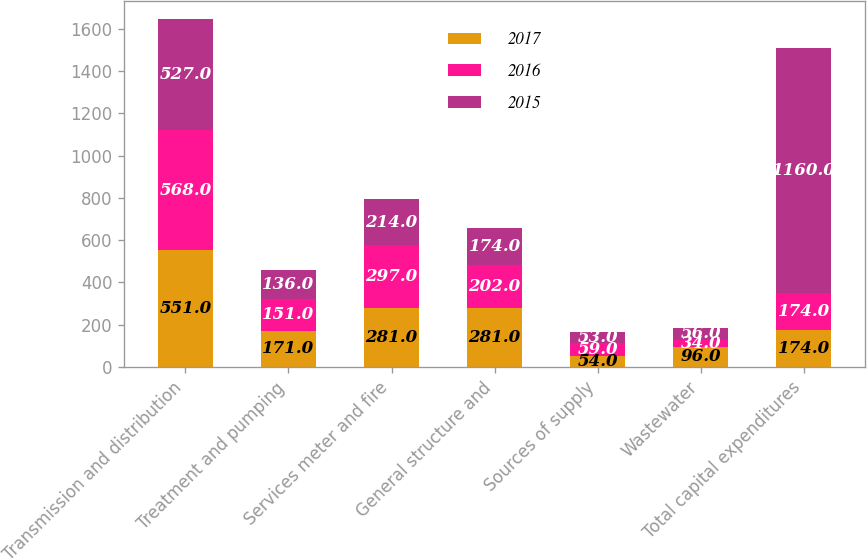<chart> <loc_0><loc_0><loc_500><loc_500><stacked_bar_chart><ecel><fcel>Transmission and distribution<fcel>Treatment and pumping<fcel>Services meter and fire<fcel>General structure and<fcel>Sources of supply<fcel>Wastewater<fcel>Total capital expenditures<nl><fcel>2017<fcel>551<fcel>171<fcel>281<fcel>281<fcel>54<fcel>96<fcel>174<nl><fcel>2016<fcel>568<fcel>151<fcel>297<fcel>202<fcel>59<fcel>34<fcel>174<nl><fcel>2015<fcel>527<fcel>136<fcel>214<fcel>174<fcel>53<fcel>56<fcel>1160<nl></chart> 